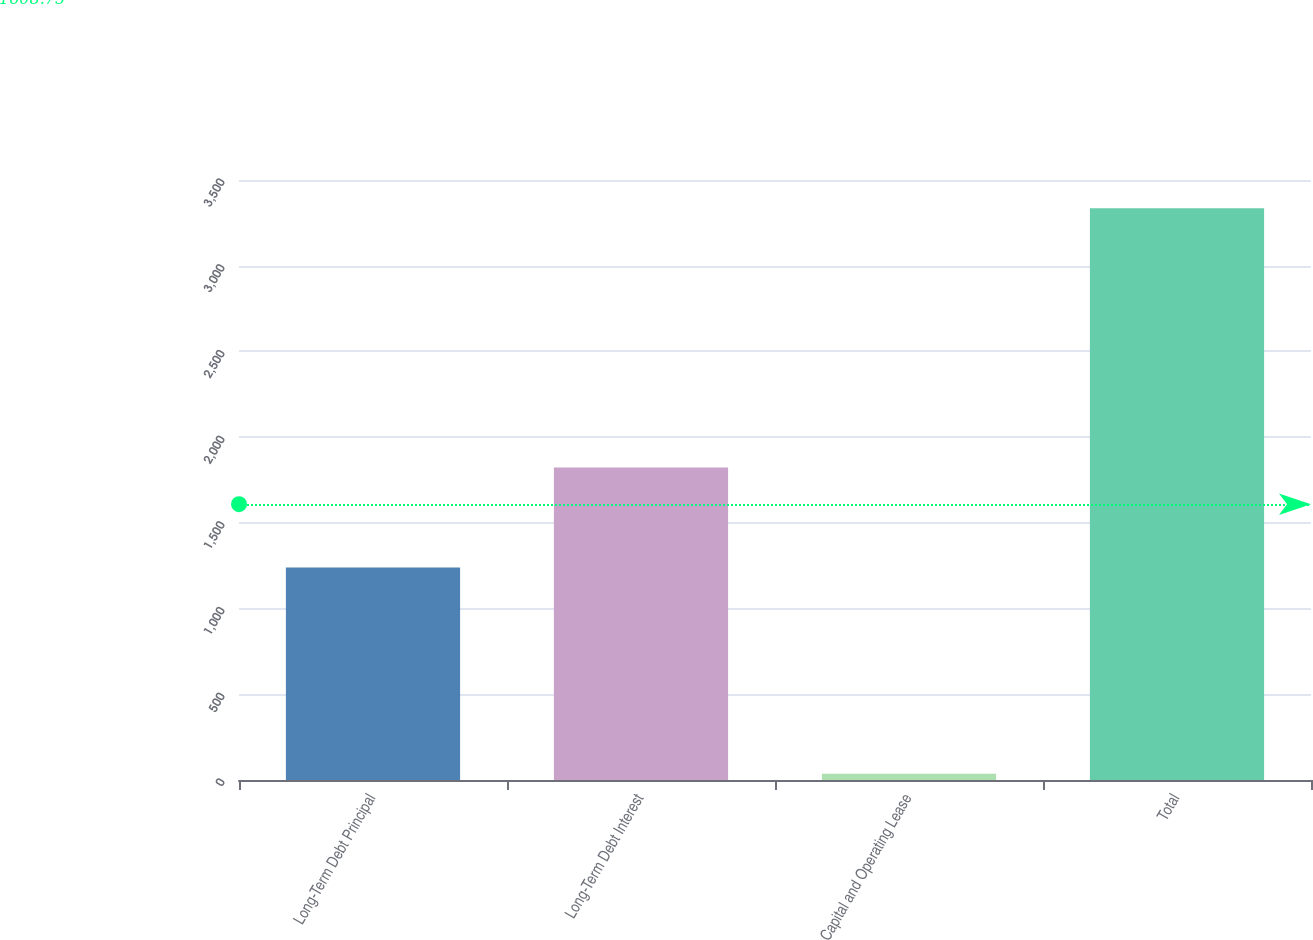Convert chart. <chart><loc_0><loc_0><loc_500><loc_500><bar_chart><fcel>Long-Term Debt Principal<fcel>Long-Term Debt Interest<fcel>Capital and Operating Lease<fcel>Total<nl><fcel>1240<fcel>1823<fcel>37<fcel>3335<nl></chart> 